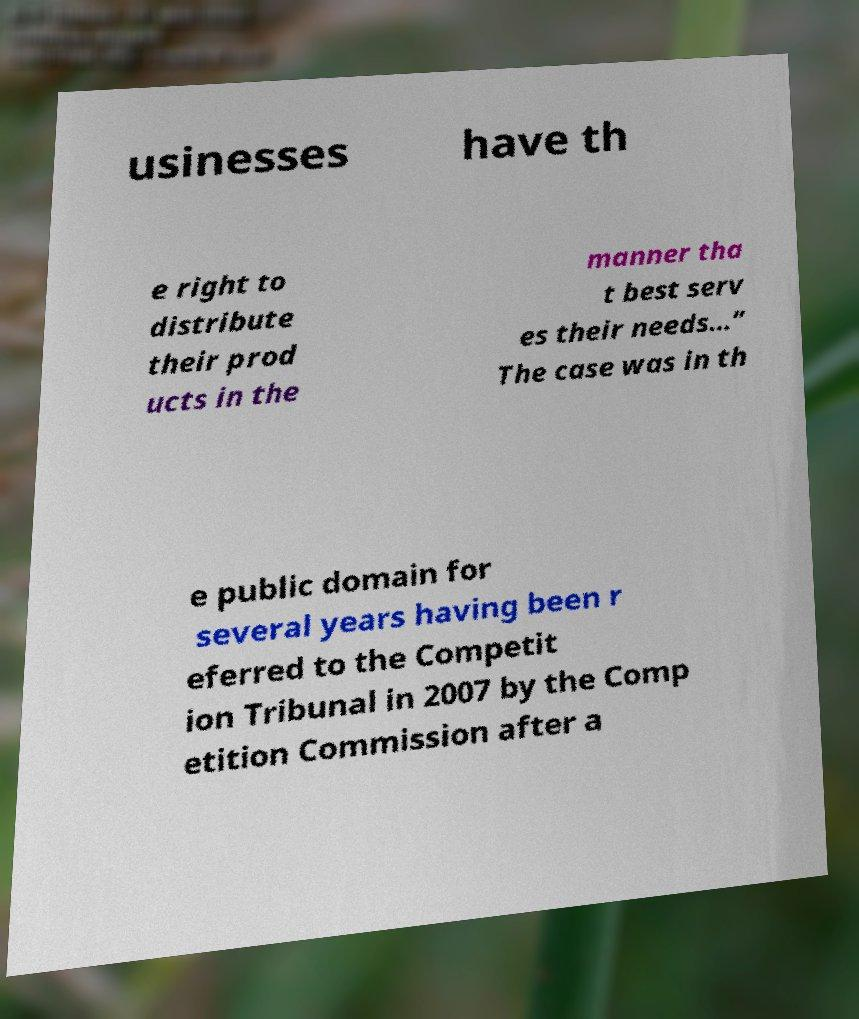Can you read and provide the text displayed in the image?This photo seems to have some interesting text. Can you extract and type it out for me? usinesses have th e right to distribute their prod ucts in the manner tha t best serv es their needs…” The case was in th e public domain for several years having been r eferred to the Competit ion Tribunal in 2007 by the Comp etition Commission after a 